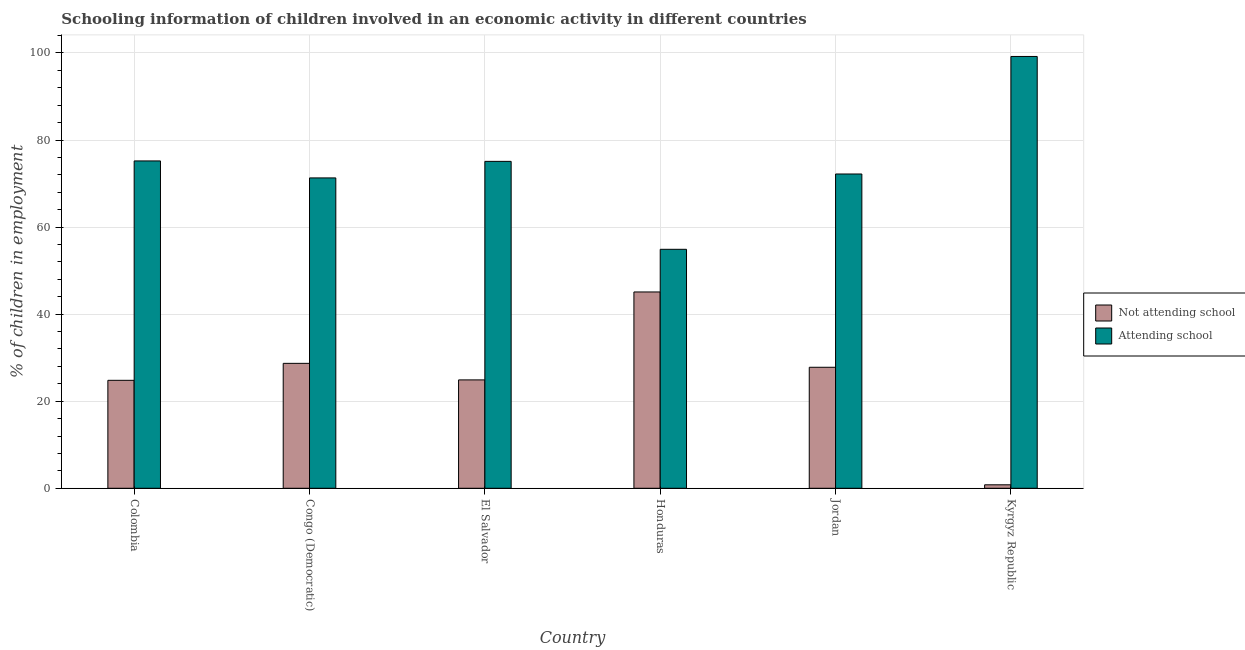How many different coloured bars are there?
Your answer should be very brief. 2. How many bars are there on the 6th tick from the left?
Provide a short and direct response. 2. How many bars are there on the 3rd tick from the right?
Your response must be concise. 2. What is the label of the 3rd group of bars from the left?
Ensure brevity in your answer.  El Salvador. In how many cases, is the number of bars for a given country not equal to the number of legend labels?
Your answer should be compact. 0. What is the percentage of employed children who are not attending school in Congo (Democratic)?
Offer a terse response. 28.7. Across all countries, what is the maximum percentage of employed children who are attending school?
Ensure brevity in your answer.  99.2. Across all countries, what is the minimum percentage of employed children who are not attending school?
Provide a short and direct response. 0.8. In which country was the percentage of employed children who are not attending school maximum?
Provide a succinct answer. Honduras. In which country was the percentage of employed children who are not attending school minimum?
Offer a very short reply. Kyrgyz Republic. What is the total percentage of employed children who are attending school in the graph?
Your answer should be compact. 447.9. What is the difference between the percentage of employed children who are attending school in Honduras and that in Jordan?
Your answer should be very brief. -17.3. What is the difference between the percentage of employed children who are not attending school in Colombia and the percentage of employed children who are attending school in El Salvador?
Keep it short and to the point. -50.3. What is the average percentage of employed children who are not attending school per country?
Keep it short and to the point. 25.35. What is the difference between the percentage of employed children who are attending school and percentage of employed children who are not attending school in Honduras?
Your response must be concise. 9.8. What is the ratio of the percentage of employed children who are not attending school in Honduras to that in Kyrgyz Republic?
Provide a succinct answer. 56.38. Is the percentage of employed children who are attending school in El Salvador less than that in Kyrgyz Republic?
Keep it short and to the point. Yes. What is the difference between the highest and the lowest percentage of employed children who are attending school?
Make the answer very short. 44.3. In how many countries, is the percentage of employed children who are not attending school greater than the average percentage of employed children who are not attending school taken over all countries?
Your response must be concise. 3. Is the sum of the percentage of employed children who are not attending school in El Salvador and Kyrgyz Republic greater than the maximum percentage of employed children who are attending school across all countries?
Offer a very short reply. No. What does the 2nd bar from the left in El Salvador represents?
Keep it short and to the point. Attending school. What does the 2nd bar from the right in Jordan represents?
Make the answer very short. Not attending school. How many bars are there?
Your response must be concise. 12. Are all the bars in the graph horizontal?
Give a very brief answer. No. How many countries are there in the graph?
Give a very brief answer. 6. What is the difference between two consecutive major ticks on the Y-axis?
Provide a succinct answer. 20. How are the legend labels stacked?
Keep it short and to the point. Vertical. What is the title of the graph?
Offer a terse response. Schooling information of children involved in an economic activity in different countries. What is the label or title of the X-axis?
Ensure brevity in your answer.  Country. What is the label or title of the Y-axis?
Keep it short and to the point. % of children in employment. What is the % of children in employment in Not attending school in Colombia?
Make the answer very short. 24.8. What is the % of children in employment of Attending school in Colombia?
Make the answer very short. 75.2. What is the % of children in employment in Not attending school in Congo (Democratic)?
Provide a succinct answer. 28.7. What is the % of children in employment in Attending school in Congo (Democratic)?
Make the answer very short. 71.3. What is the % of children in employment in Not attending school in El Salvador?
Your answer should be compact. 24.9. What is the % of children in employment in Attending school in El Salvador?
Your answer should be compact. 75.1. What is the % of children in employment of Not attending school in Honduras?
Offer a terse response. 45.1. What is the % of children in employment of Attending school in Honduras?
Offer a very short reply. 54.9. What is the % of children in employment in Not attending school in Jordan?
Make the answer very short. 27.8. What is the % of children in employment in Attending school in Jordan?
Make the answer very short. 72.2. What is the % of children in employment in Not attending school in Kyrgyz Republic?
Ensure brevity in your answer.  0.8. What is the % of children in employment of Attending school in Kyrgyz Republic?
Your answer should be very brief. 99.2. Across all countries, what is the maximum % of children in employment in Not attending school?
Keep it short and to the point. 45.1. Across all countries, what is the maximum % of children in employment of Attending school?
Make the answer very short. 99.2. Across all countries, what is the minimum % of children in employment in Attending school?
Make the answer very short. 54.9. What is the total % of children in employment of Not attending school in the graph?
Make the answer very short. 152.1. What is the total % of children in employment in Attending school in the graph?
Offer a terse response. 447.9. What is the difference between the % of children in employment of Not attending school in Colombia and that in Honduras?
Offer a very short reply. -20.3. What is the difference between the % of children in employment in Attending school in Colombia and that in Honduras?
Make the answer very short. 20.3. What is the difference between the % of children in employment in Attending school in Colombia and that in Kyrgyz Republic?
Provide a succinct answer. -24. What is the difference between the % of children in employment of Not attending school in Congo (Democratic) and that in El Salvador?
Your response must be concise. 3.8. What is the difference between the % of children in employment of Not attending school in Congo (Democratic) and that in Honduras?
Your answer should be very brief. -16.4. What is the difference between the % of children in employment in Attending school in Congo (Democratic) and that in Honduras?
Offer a terse response. 16.4. What is the difference between the % of children in employment in Attending school in Congo (Democratic) and that in Jordan?
Make the answer very short. -0.9. What is the difference between the % of children in employment in Not attending school in Congo (Democratic) and that in Kyrgyz Republic?
Provide a succinct answer. 27.9. What is the difference between the % of children in employment of Attending school in Congo (Democratic) and that in Kyrgyz Republic?
Provide a succinct answer. -27.9. What is the difference between the % of children in employment of Not attending school in El Salvador and that in Honduras?
Provide a succinct answer. -20.2. What is the difference between the % of children in employment of Attending school in El Salvador and that in Honduras?
Offer a terse response. 20.2. What is the difference between the % of children in employment in Not attending school in El Salvador and that in Jordan?
Make the answer very short. -2.9. What is the difference between the % of children in employment of Not attending school in El Salvador and that in Kyrgyz Republic?
Give a very brief answer. 24.1. What is the difference between the % of children in employment in Attending school in El Salvador and that in Kyrgyz Republic?
Keep it short and to the point. -24.1. What is the difference between the % of children in employment in Not attending school in Honduras and that in Jordan?
Ensure brevity in your answer.  17.3. What is the difference between the % of children in employment in Attending school in Honduras and that in Jordan?
Give a very brief answer. -17.3. What is the difference between the % of children in employment in Not attending school in Honduras and that in Kyrgyz Republic?
Offer a terse response. 44.3. What is the difference between the % of children in employment in Attending school in Honduras and that in Kyrgyz Republic?
Keep it short and to the point. -44.3. What is the difference between the % of children in employment of Attending school in Jordan and that in Kyrgyz Republic?
Give a very brief answer. -27. What is the difference between the % of children in employment of Not attending school in Colombia and the % of children in employment of Attending school in Congo (Democratic)?
Provide a succinct answer. -46.5. What is the difference between the % of children in employment of Not attending school in Colombia and the % of children in employment of Attending school in El Salvador?
Keep it short and to the point. -50.3. What is the difference between the % of children in employment of Not attending school in Colombia and the % of children in employment of Attending school in Honduras?
Offer a very short reply. -30.1. What is the difference between the % of children in employment in Not attending school in Colombia and the % of children in employment in Attending school in Jordan?
Make the answer very short. -47.4. What is the difference between the % of children in employment in Not attending school in Colombia and the % of children in employment in Attending school in Kyrgyz Republic?
Keep it short and to the point. -74.4. What is the difference between the % of children in employment in Not attending school in Congo (Democratic) and the % of children in employment in Attending school in El Salvador?
Your answer should be compact. -46.4. What is the difference between the % of children in employment in Not attending school in Congo (Democratic) and the % of children in employment in Attending school in Honduras?
Your answer should be very brief. -26.2. What is the difference between the % of children in employment of Not attending school in Congo (Democratic) and the % of children in employment of Attending school in Jordan?
Ensure brevity in your answer.  -43.5. What is the difference between the % of children in employment of Not attending school in Congo (Democratic) and the % of children in employment of Attending school in Kyrgyz Republic?
Provide a succinct answer. -70.5. What is the difference between the % of children in employment of Not attending school in El Salvador and the % of children in employment of Attending school in Jordan?
Offer a terse response. -47.3. What is the difference between the % of children in employment in Not attending school in El Salvador and the % of children in employment in Attending school in Kyrgyz Republic?
Ensure brevity in your answer.  -74.3. What is the difference between the % of children in employment in Not attending school in Honduras and the % of children in employment in Attending school in Jordan?
Provide a succinct answer. -27.1. What is the difference between the % of children in employment in Not attending school in Honduras and the % of children in employment in Attending school in Kyrgyz Republic?
Your response must be concise. -54.1. What is the difference between the % of children in employment in Not attending school in Jordan and the % of children in employment in Attending school in Kyrgyz Republic?
Offer a very short reply. -71.4. What is the average % of children in employment in Not attending school per country?
Give a very brief answer. 25.35. What is the average % of children in employment of Attending school per country?
Provide a short and direct response. 74.65. What is the difference between the % of children in employment in Not attending school and % of children in employment in Attending school in Colombia?
Your answer should be very brief. -50.4. What is the difference between the % of children in employment in Not attending school and % of children in employment in Attending school in Congo (Democratic)?
Provide a succinct answer. -42.6. What is the difference between the % of children in employment in Not attending school and % of children in employment in Attending school in El Salvador?
Keep it short and to the point. -50.2. What is the difference between the % of children in employment of Not attending school and % of children in employment of Attending school in Honduras?
Offer a very short reply. -9.8. What is the difference between the % of children in employment in Not attending school and % of children in employment in Attending school in Jordan?
Your response must be concise. -44.4. What is the difference between the % of children in employment in Not attending school and % of children in employment in Attending school in Kyrgyz Republic?
Your answer should be compact. -98.4. What is the ratio of the % of children in employment in Not attending school in Colombia to that in Congo (Democratic)?
Your answer should be very brief. 0.86. What is the ratio of the % of children in employment of Attending school in Colombia to that in Congo (Democratic)?
Give a very brief answer. 1.05. What is the ratio of the % of children in employment in Not attending school in Colombia to that in El Salvador?
Provide a succinct answer. 1. What is the ratio of the % of children in employment of Attending school in Colombia to that in El Salvador?
Offer a very short reply. 1. What is the ratio of the % of children in employment of Not attending school in Colombia to that in Honduras?
Your answer should be very brief. 0.55. What is the ratio of the % of children in employment in Attending school in Colombia to that in Honduras?
Keep it short and to the point. 1.37. What is the ratio of the % of children in employment in Not attending school in Colombia to that in Jordan?
Give a very brief answer. 0.89. What is the ratio of the % of children in employment in Attending school in Colombia to that in Jordan?
Ensure brevity in your answer.  1.04. What is the ratio of the % of children in employment in Attending school in Colombia to that in Kyrgyz Republic?
Keep it short and to the point. 0.76. What is the ratio of the % of children in employment of Not attending school in Congo (Democratic) to that in El Salvador?
Ensure brevity in your answer.  1.15. What is the ratio of the % of children in employment of Attending school in Congo (Democratic) to that in El Salvador?
Provide a short and direct response. 0.95. What is the ratio of the % of children in employment in Not attending school in Congo (Democratic) to that in Honduras?
Your response must be concise. 0.64. What is the ratio of the % of children in employment in Attending school in Congo (Democratic) to that in Honduras?
Offer a terse response. 1.3. What is the ratio of the % of children in employment of Not attending school in Congo (Democratic) to that in Jordan?
Keep it short and to the point. 1.03. What is the ratio of the % of children in employment in Attending school in Congo (Democratic) to that in Jordan?
Make the answer very short. 0.99. What is the ratio of the % of children in employment of Not attending school in Congo (Democratic) to that in Kyrgyz Republic?
Your answer should be very brief. 35.88. What is the ratio of the % of children in employment of Attending school in Congo (Democratic) to that in Kyrgyz Republic?
Make the answer very short. 0.72. What is the ratio of the % of children in employment of Not attending school in El Salvador to that in Honduras?
Offer a terse response. 0.55. What is the ratio of the % of children in employment in Attending school in El Salvador to that in Honduras?
Keep it short and to the point. 1.37. What is the ratio of the % of children in employment in Not attending school in El Salvador to that in Jordan?
Your answer should be compact. 0.9. What is the ratio of the % of children in employment of Attending school in El Salvador to that in Jordan?
Make the answer very short. 1.04. What is the ratio of the % of children in employment in Not attending school in El Salvador to that in Kyrgyz Republic?
Your response must be concise. 31.12. What is the ratio of the % of children in employment in Attending school in El Salvador to that in Kyrgyz Republic?
Give a very brief answer. 0.76. What is the ratio of the % of children in employment in Not attending school in Honduras to that in Jordan?
Provide a short and direct response. 1.62. What is the ratio of the % of children in employment of Attending school in Honduras to that in Jordan?
Your answer should be compact. 0.76. What is the ratio of the % of children in employment in Not attending school in Honduras to that in Kyrgyz Republic?
Keep it short and to the point. 56.38. What is the ratio of the % of children in employment of Attending school in Honduras to that in Kyrgyz Republic?
Ensure brevity in your answer.  0.55. What is the ratio of the % of children in employment in Not attending school in Jordan to that in Kyrgyz Republic?
Make the answer very short. 34.75. What is the ratio of the % of children in employment of Attending school in Jordan to that in Kyrgyz Republic?
Give a very brief answer. 0.73. What is the difference between the highest and the second highest % of children in employment in Not attending school?
Provide a succinct answer. 16.4. What is the difference between the highest and the second highest % of children in employment of Attending school?
Provide a succinct answer. 24. What is the difference between the highest and the lowest % of children in employment of Not attending school?
Your response must be concise. 44.3. What is the difference between the highest and the lowest % of children in employment of Attending school?
Offer a terse response. 44.3. 